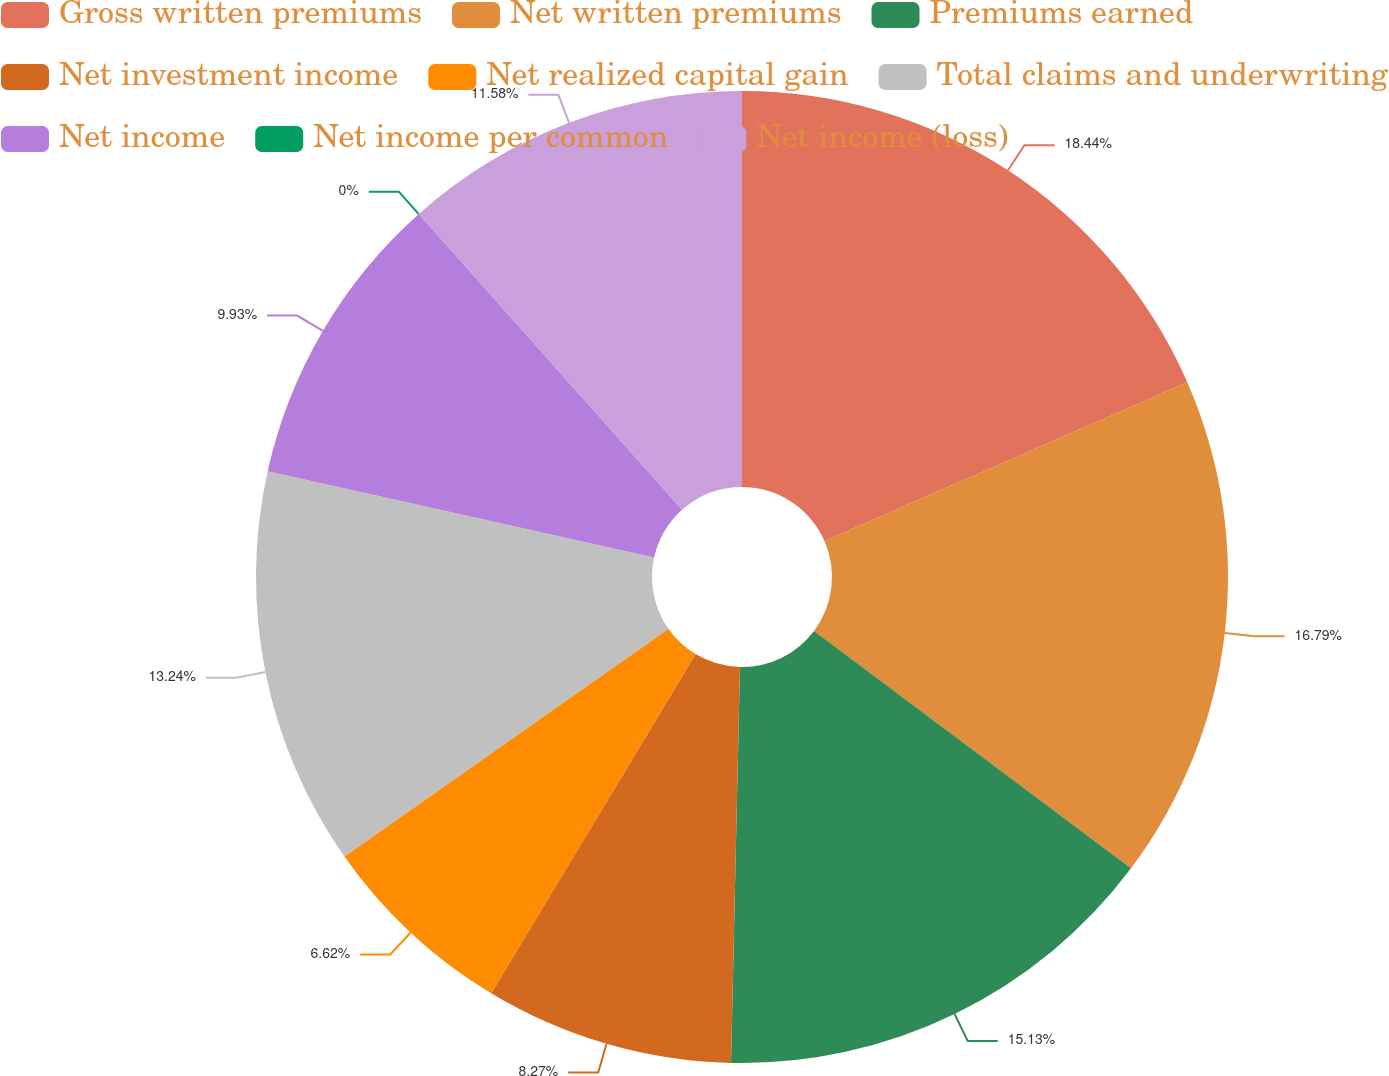Convert chart to OTSL. <chart><loc_0><loc_0><loc_500><loc_500><pie_chart><fcel>Gross written premiums<fcel>Net written premiums<fcel>Premiums earned<fcel>Net investment income<fcel>Net realized capital gain<fcel>Total claims and underwriting<fcel>Net income<fcel>Net income per common<fcel>Net income (loss)<nl><fcel>18.44%<fcel>16.79%<fcel>15.13%<fcel>8.27%<fcel>6.62%<fcel>13.24%<fcel>9.93%<fcel>0.0%<fcel>11.58%<nl></chart> 